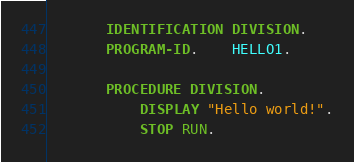Convert code to text. <code><loc_0><loc_0><loc_500><loc_500><_COBOL_>       IDENTIFICATION DIVISION.
       PROGRAM-ID.    HELLO1.

       PROCEDURE DIVISION.
           DISPLAY "Hello world!".
           STOP RUN.</code> 